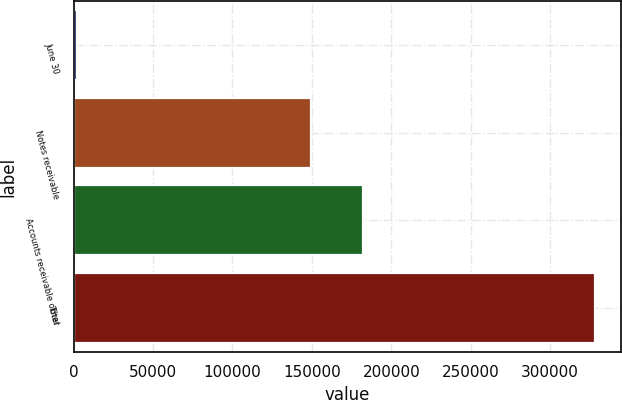<chart> <loc_0><loc_0><loc_500><loc_500><bar_chart><fcel>June 30<fcel>Notes receivable<fcel>Accounts receivable other<fcel>Total<nl><fcel>2018<fcel>149254<fcel>181892<fcel>328399<nl></chart> 